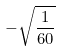Convert formula to latex. <formula><loc_0><loc_0><loc_500><loc_500>- \sqrt { \frac { 1 } { 6 0 } }</formula> 